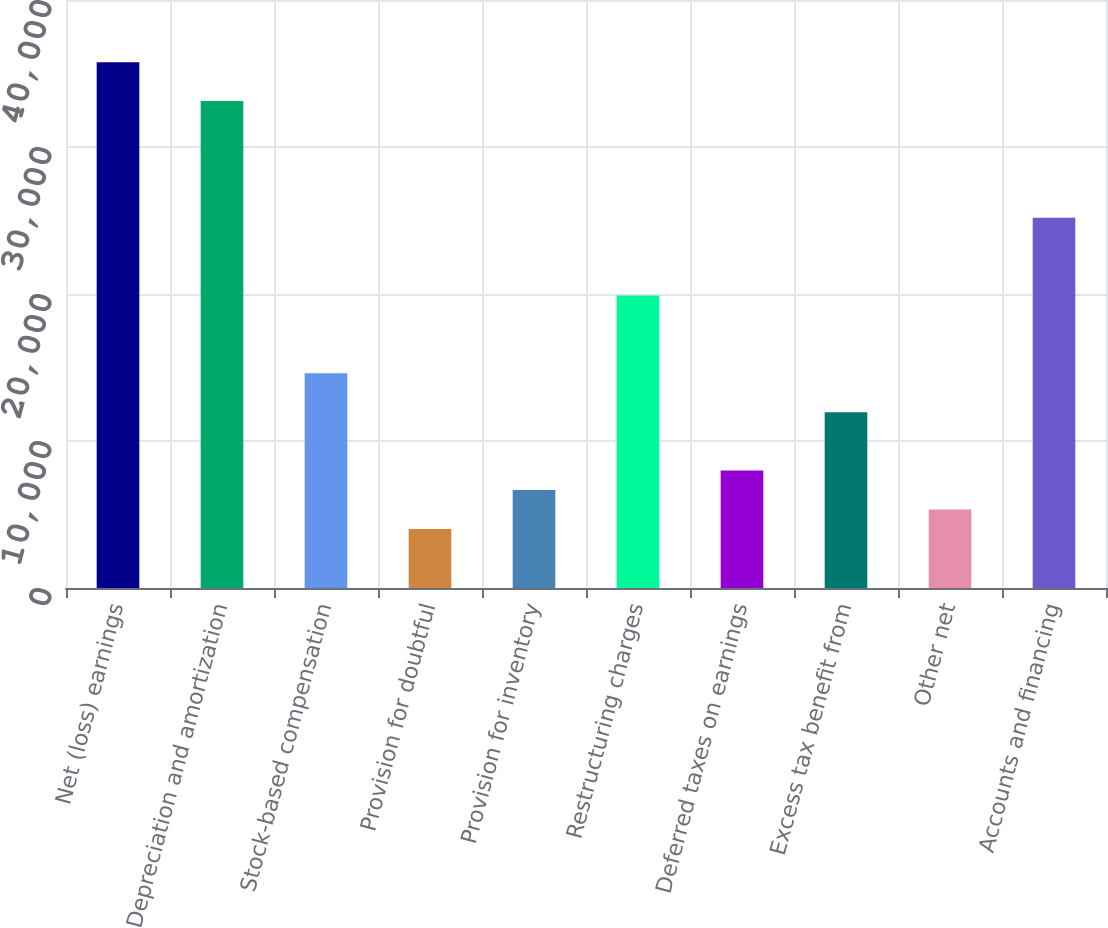Convert chart. <chart><loc_0><loc_0><loc_500><loc_500><bar_chart><fcel>Net (loss) earnings<fcel>Depreciation and amortization<fcel>Stock-based compensation<fcel>Provision for doubtful<fcel>Provision for inventory<fcel>Restructuring charges<fcel>Deferred taxes on earnings<fcel>Excess tax benefit from<fcel>Other net<fcel>Accounts and financing<nl><fcel>35766.6<fcel>33121<fcel>14601.8<fcel>4019.4<fcel>6665<fcel>19893<fcel>7987.8<fcel>11956.2<fcel>5342.2<fcel>25184.2<nl></chart> 